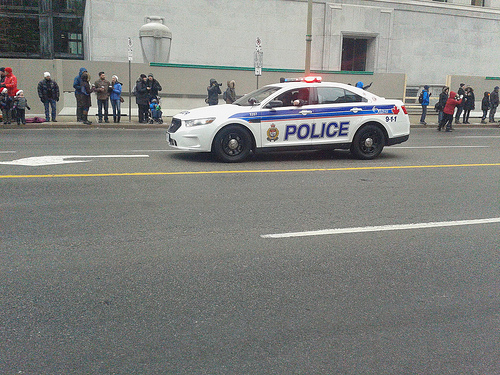<image>
Is the police car in front of the person? Yes. The police car is positioned in front of the person, appearing closer to the camera viewpoint. 